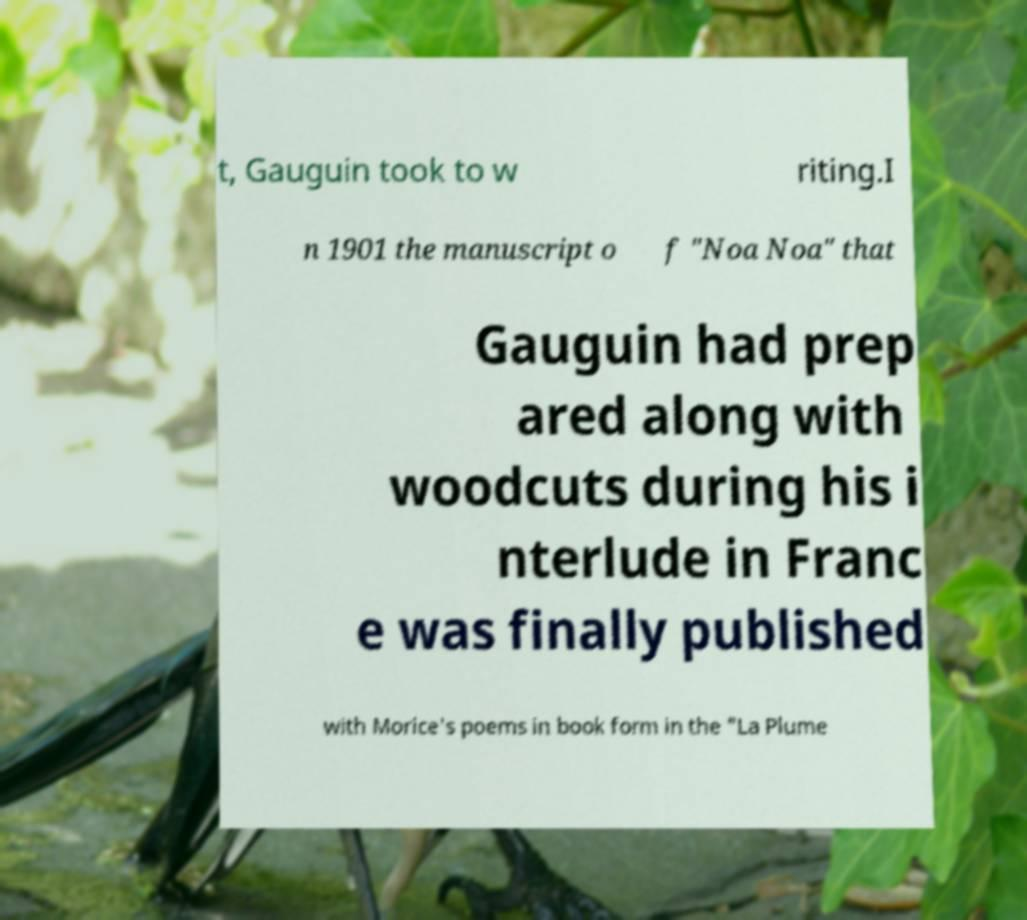Please read and relay the text visible in this image. What does it say? t, Gauguin took to w riting.I n 1901 the manuscript o f "Noa Noa" that Gauguin had prep ared along with woodcuts during his i nterlude in Franc e was finally published with Morice's poems in book form in the "La Plume 